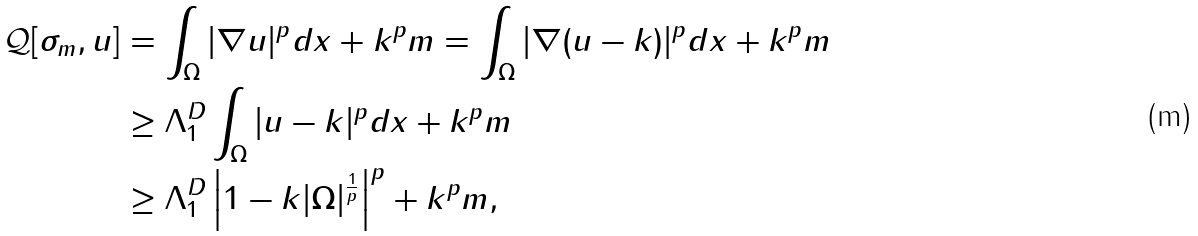<formula> <loc_0><loc_0><loc_500><loc_500>\mathcal { Q } [ \sigma _ { m } , u ] & = \int _ { \Omega } | \nabla u | ^ { p } d x + k ^ { p } m = \int _ { \Omega } | \nabla ( u - k ) | ^ { p } d x + k ^ { p } m \\ & \geq \Lambda _ { 1 } ^ { D } \int _ { \Omega } | u - k | ^ { p } d x + k ^ { p } m \\ & \geq \Lambda _ { 1 } ^ { D } \left | 1 - k | \Omega | ^ { \frac { 1 } { p } } \right | ^ { p } + k ^ { p } m ,</formula> 